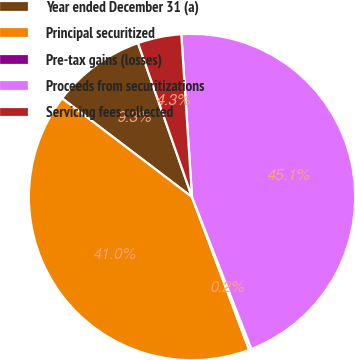<chart> <loc_0><loc_0><loc_500><loc_500><pie_chart><fcel>Year ended December 31 (a)<fcel>Principal securitized<fcel>Pre-tax gains (losses)<fcel>Proceeds from securitizations<fcel>Servicing fees collected<nl><fcel>9.29%<fcel>41.03%<fcel>0.24%<fcel>45.11%<fcel>4.32%<nl></chart> 